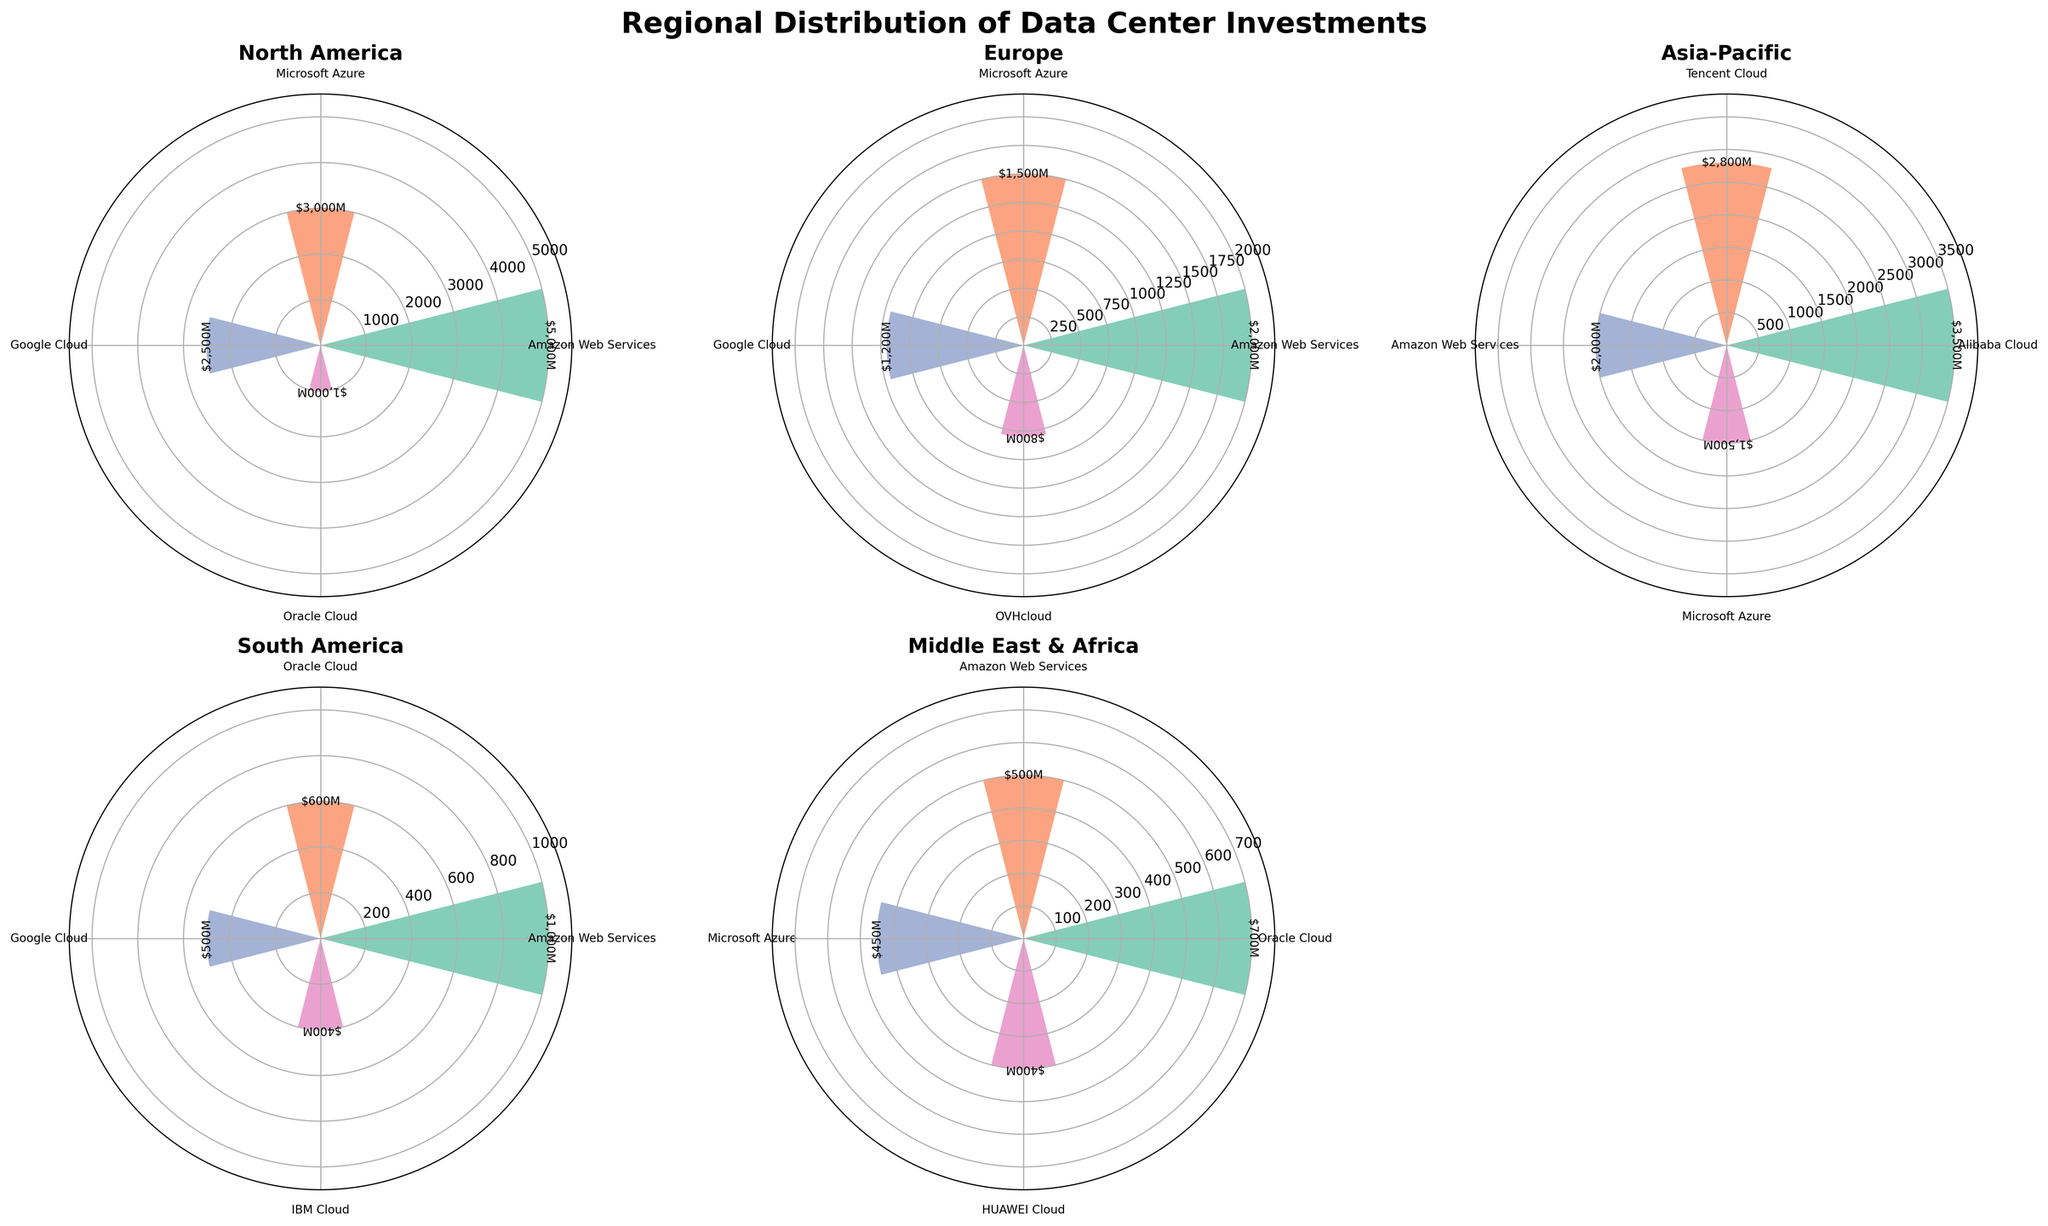Which region has the highest total data center investment? Add the investment values for all companies in each region. North America: 5000 + 3000 + 2500 + 1000 = 11500M USD; Europe: 2000 + 1500 + 1200 + 800 = 5500M USD; Asia-Pacific: 3500 + 2800 + 2000 + 1500 = 9800M USD; South America: 1000 + 600 + 500 + 400 = 2500M USD; Middle East & Africa: 700 + 500 + 450 + 400 = 2050M USD. Therefore, North America has the highest total investment.
Answer: North America Which company has the highest investment in the Asia-Pacific region? Based on the plot for the Asia-Pacific region, the company with the highest investment bar is Alibaba Cloud (3500M USD).
Answer: Alibaba Cloud What is the average investment for Amazon Web Services across all regions? Compute the sum of investments for Amazon Web Services and divide by the number of regions they are present in. Investments: 5000 (NA) + 2000 (Europe) + 2000 (Asia-Pacific) + 1000 (SA) + 500 (MEA) = 10500M USD. Number of regions: 5. Average investment: 10500/5 = 2100M USD.
Answer: 2100M USD Which company has the smallest investment in Europe? In the Europe subplot, the company with the smallest investment value is OVHcloud with 800M USD.
Answer: OVHcloud How does the investment of Microsoft Azure in Middle East & Africa compare with its investment in North America? Compare the investment values directly. Middle East & Africa: 450M USD, North America: 3000M USD. Microsoft Azure’s investment in North America is significantly higher.
Answer: North America > Middle East & Africa What is the total investment in South America by non-US based companies? Sum the investments for non-US based companies (Oracle Cloud, Google Cloud, IBM Cloud). Oracle Cloud: 600M USD, Google Cloud: 500M USD, IBM Cloud: 400M USD. Total is 600 + 500 + 400 = 1500M USD.
Answer: 1500M USD Which region shows the most diverse range of companies investing in data centers? Count the unique companies in each region. North America: 4, Europe: 4, Asia-Pacific: 4, South America: 4, Middle East & Africa: 4. All regions have the same number of different companies.
Answer: All regions What is the combined investment of Alibaba Cloud and Tencent Cloud in the Asia-Pacific region? Add the investment values of Alibaba Cloud and Tencent Cloud in the Asia-Pacific region. Alibaba Cloud: 3500M USD, Tencent Cloud: 2800M USD. Combined investment: 3500 + 2800 = 6300M USD.
Answer: 6300M USD Is Oracle Cloud's total investment higher in South America or Middle East & Africa? Compare Oracle Cloud’s investments: South America: 600M USD, Middle East & Africa: 700M USD. Oracle Cloud’s total investment is higher in the Middle East & Africa.
Answer: Middle East & Africa Identify the region where Amazon Web Services has the lowest investment amount. Compare AWS’s investment across regions: North America: 5000M USD, Europe: 2000M USD, Asia-Pacific: 2000M USD, South America: 1000M USD, Middle East & Africa: 500M USD. The lowest investment is in Middle East & Africa.
Answer: Middle East & Africa 